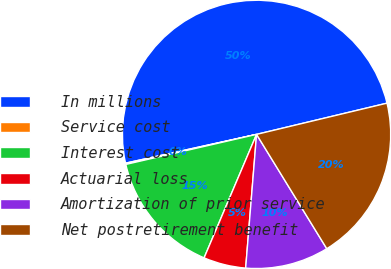Convert chart to OTSL. <chart><loc_0><loc_0><loc_500><loc_500><pie_chart><fcel>In millions<fcel>Service cost<fcel>Interest cost<fcel>Actuarial loss<fcel>Amortization of prior service<fcel>Net postretirement benefit<nl><fcel>49.7%<fcel>0.15%<fcel>15.01%<fcel>5.1%<fcel>10.06%<fcel>19.97%<nl></chart> 